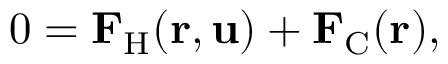Convert formula to latex. <formula><loc_0><loc_0><loc_500><loc_500>0 = F _ { H } ( r , u ) + F _ { C } ( r ) ,</formula> 